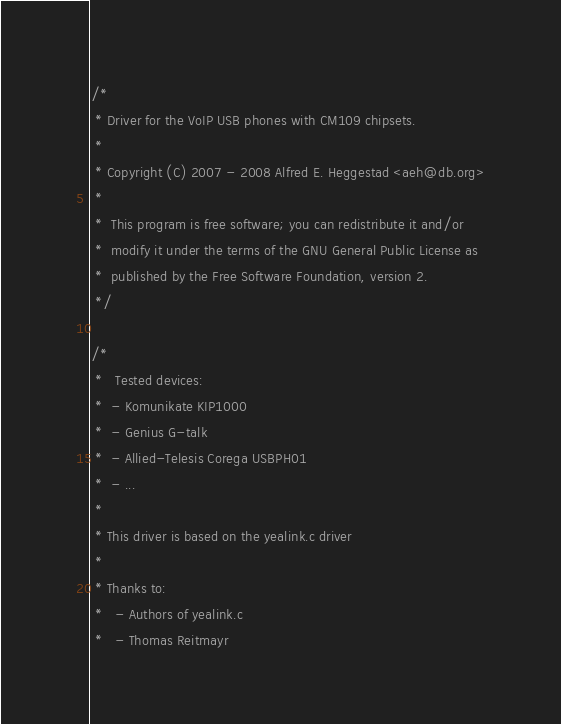<code> <loc_0><loc_0><loc_500><loc_500><_C_>/*
 * Driver for the VoIP USB phones with CM109 chipsets.
 *
 * Copyright (C) 2007 - 2008 Alfred E. Heggestad <aeh@db.org>
 *
 *	This program is free software; you can redistribute it and/or
 *	modify it under the terms of the GNU General Public License as
 *	published by the Free Software Foundation, version 2.
 */

/*
 *   Tested devices:
 *	- Komunikate KIP1000
 *	- Genius G-talk
 *	- Allied-Telesis Corega USBPH01
 *	- ...
 *
 * This driver is based on the yealink.c driver
 *
 * Thanks to:
 *   - Authors of yealink.c
 *   - Thomas Reitmayr</code> 